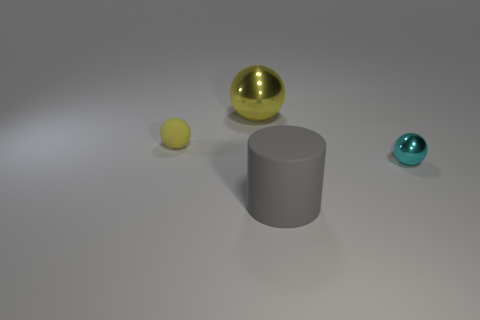Is there anything else that is the same shape as the large gray rubber thing?
Offer a very short reply. No. Are there an equal number of large gray objects that are behind the cylinder and yellow balls?
Offer a terse response. No. Do the gray cylinder and the yellow object behind the tiny yellow thing have the same size?
Offer a very short reply. Yes. How many large yellow things are the same material as the large gray cylinder?
Keep it short and to the point. 0. Do the gray thing and the yellow shiny thing have the same size?
Your answer should be very brief. Yes. Is there anything else that is the same color as the small metal ball?
Keep it short and to the point. No. There is a thing that is behind the cyan shiny ball and in front of the big yellow object; what shape is it?
Give a very brief answer. Sphere. There is a rubber object in front of the small cyan metal thing; what size is it?
Give a very brief answer. Large. There is a metallic sphere behind the sphere that is on the left side of the yellow metal object; how many gray things are to the right of it?
Give a very brief answer. 1. Are there any large yellow spheres to the right of the large yellow shiny object?
Give a very brief answer. No. 